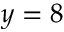<formula> <loc_0><loc_0><loc_500><loc_500>y = 8</formula> 